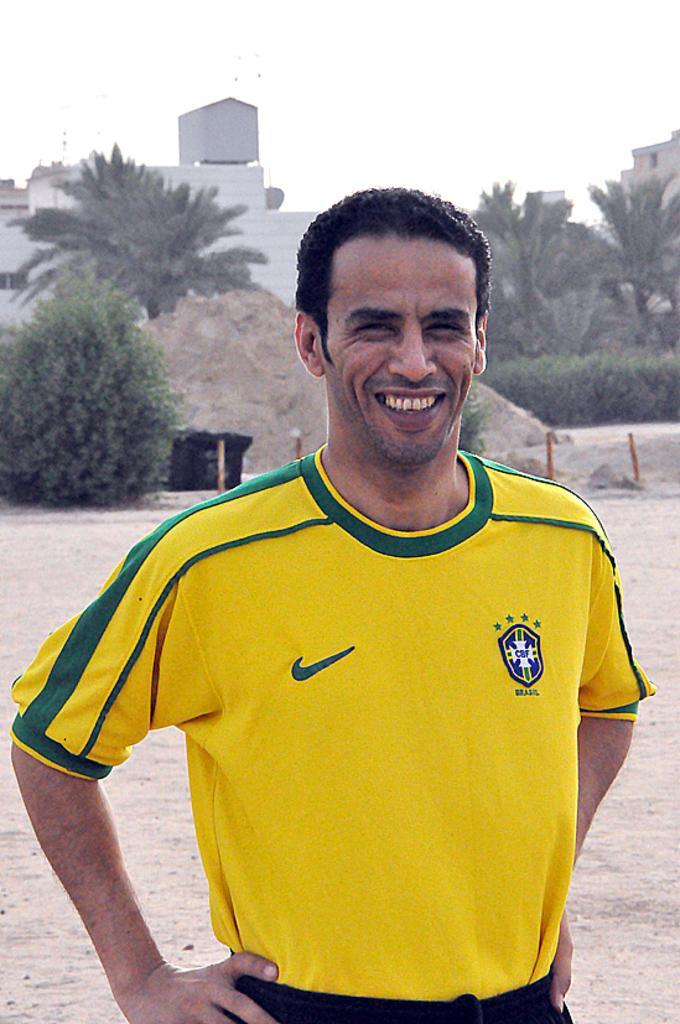Can you describe this image briefly? This image consists of trees back side. There is a building back side. In the front there is a person who is wearing yellow shirt with black pant. He is smiling. 